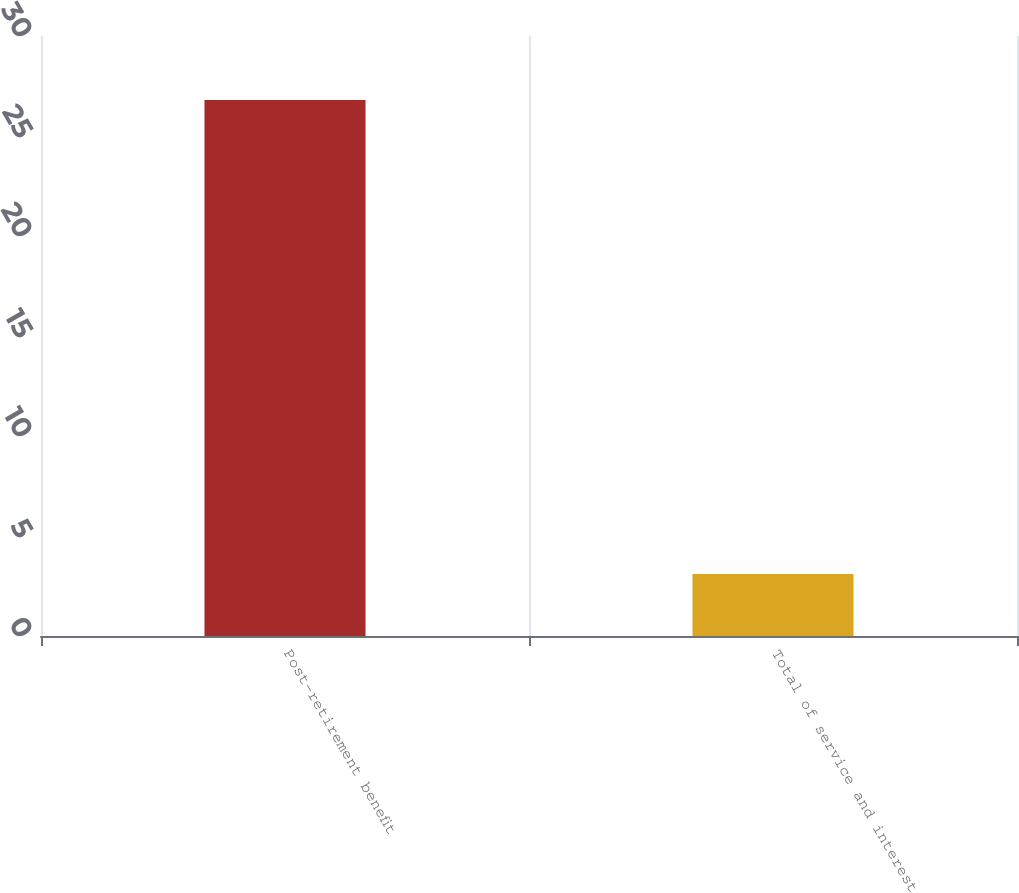Convert chart to OTSL. <chart><loc_0><loc_0><loc_500><loc_500><bar_chart><fcel>Post-retirement benefit<fcel>Total of service and interest<nl><fcel>26.8<fcel>3.1<nl></chart> 